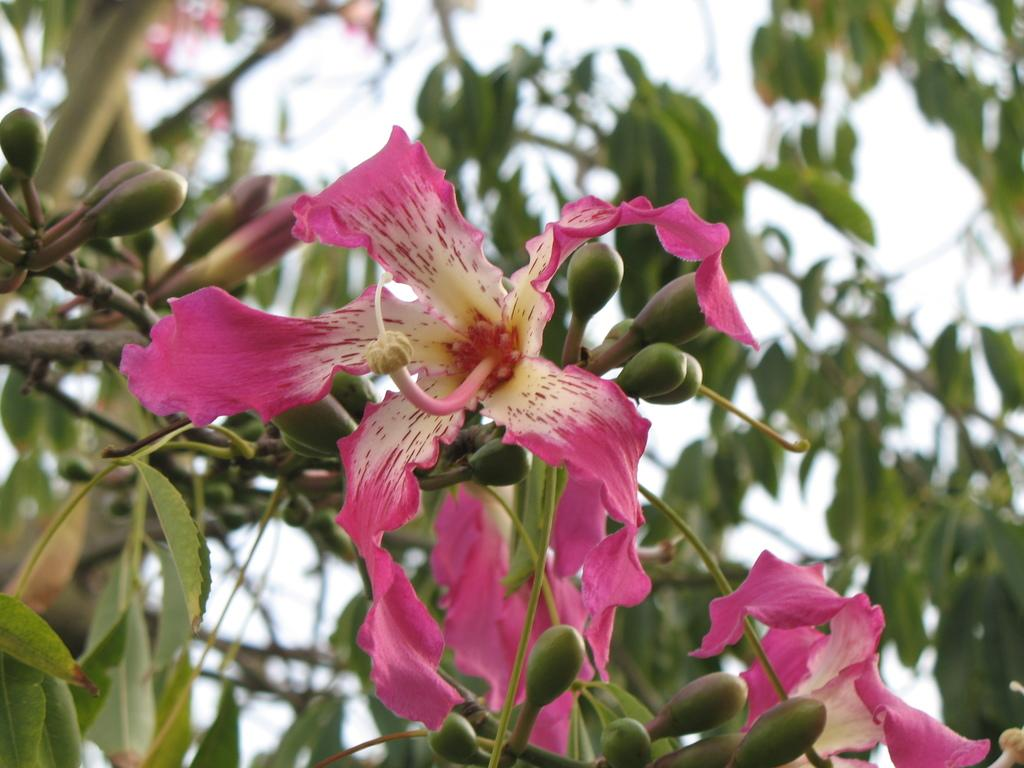What is the main subject of the image? The main subject of the image is a tree. What can be observed about the tree in the image? The tree has flowers and buds. How would you describe the background of the image? The background of the image is blurred. What type of weather can be seen in the image? There is no weather visible in the image; it only shows a tree with flowers and buds, and a blurred background. What scientific experiment is being conducted in the image? There is no scientific experiment depicted in the image; it only shows a tree with flowers and buds, and a blurred background. 